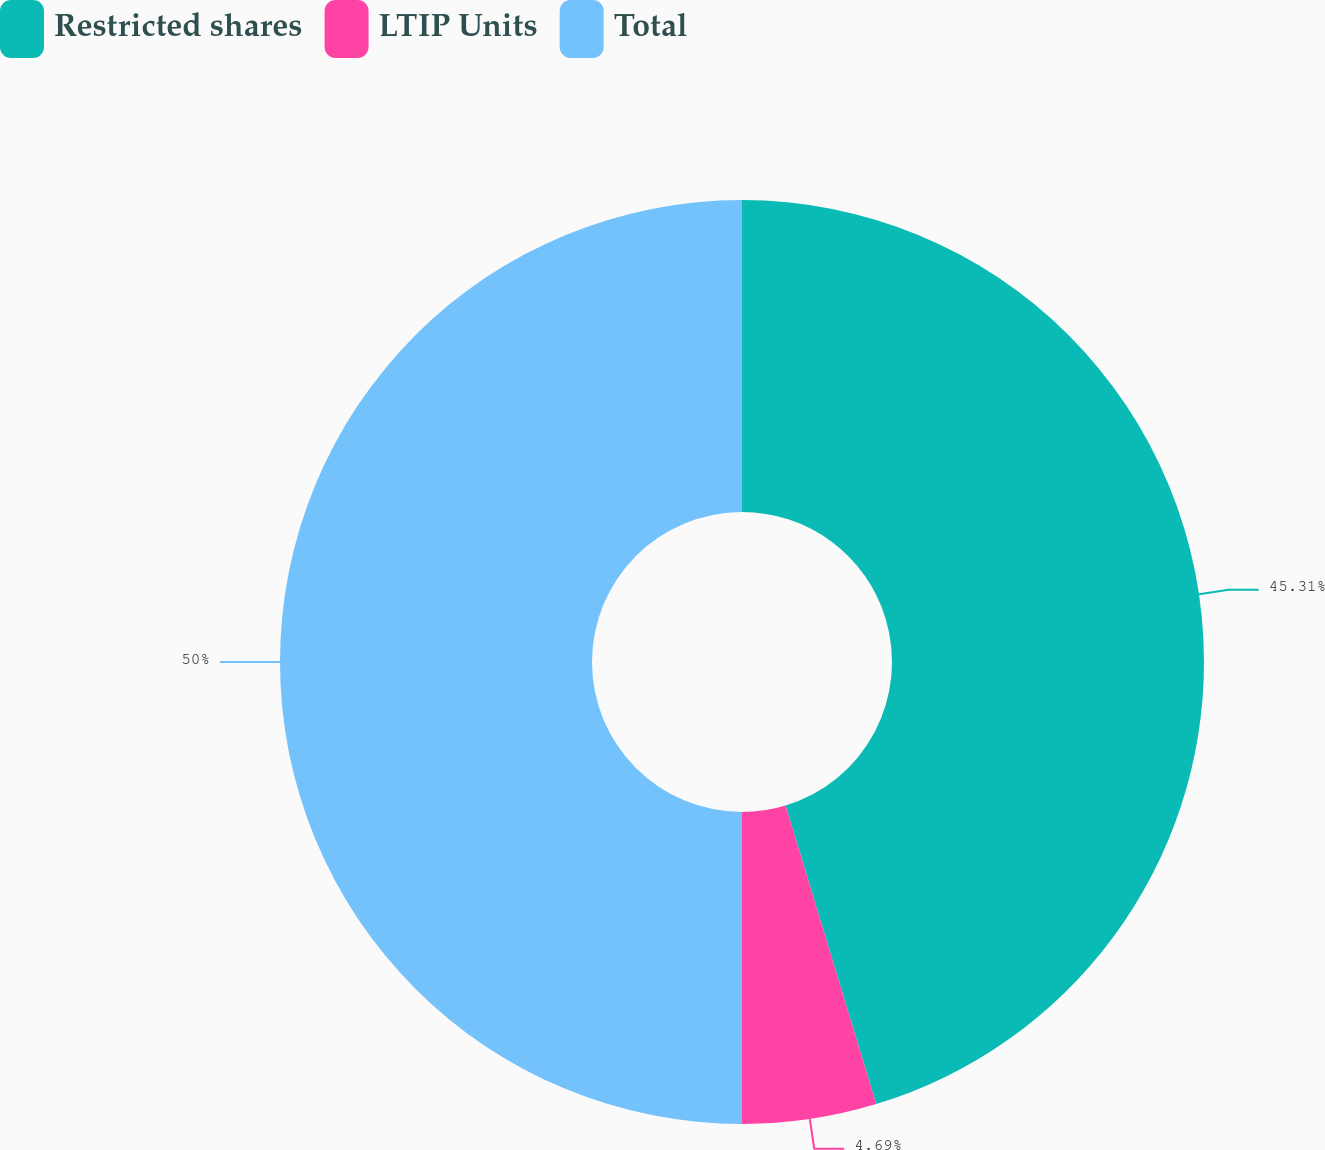Convert chart to OTSL. <chart><loc_0><loc_0><loc_500><loc_500><pie_chart><fcel>Restricted shares<fcel>LTIP Units<fcel>Total<nl><fcel>45.31%<fcel>4.69%<fcel>50.0%<nl></chart> 